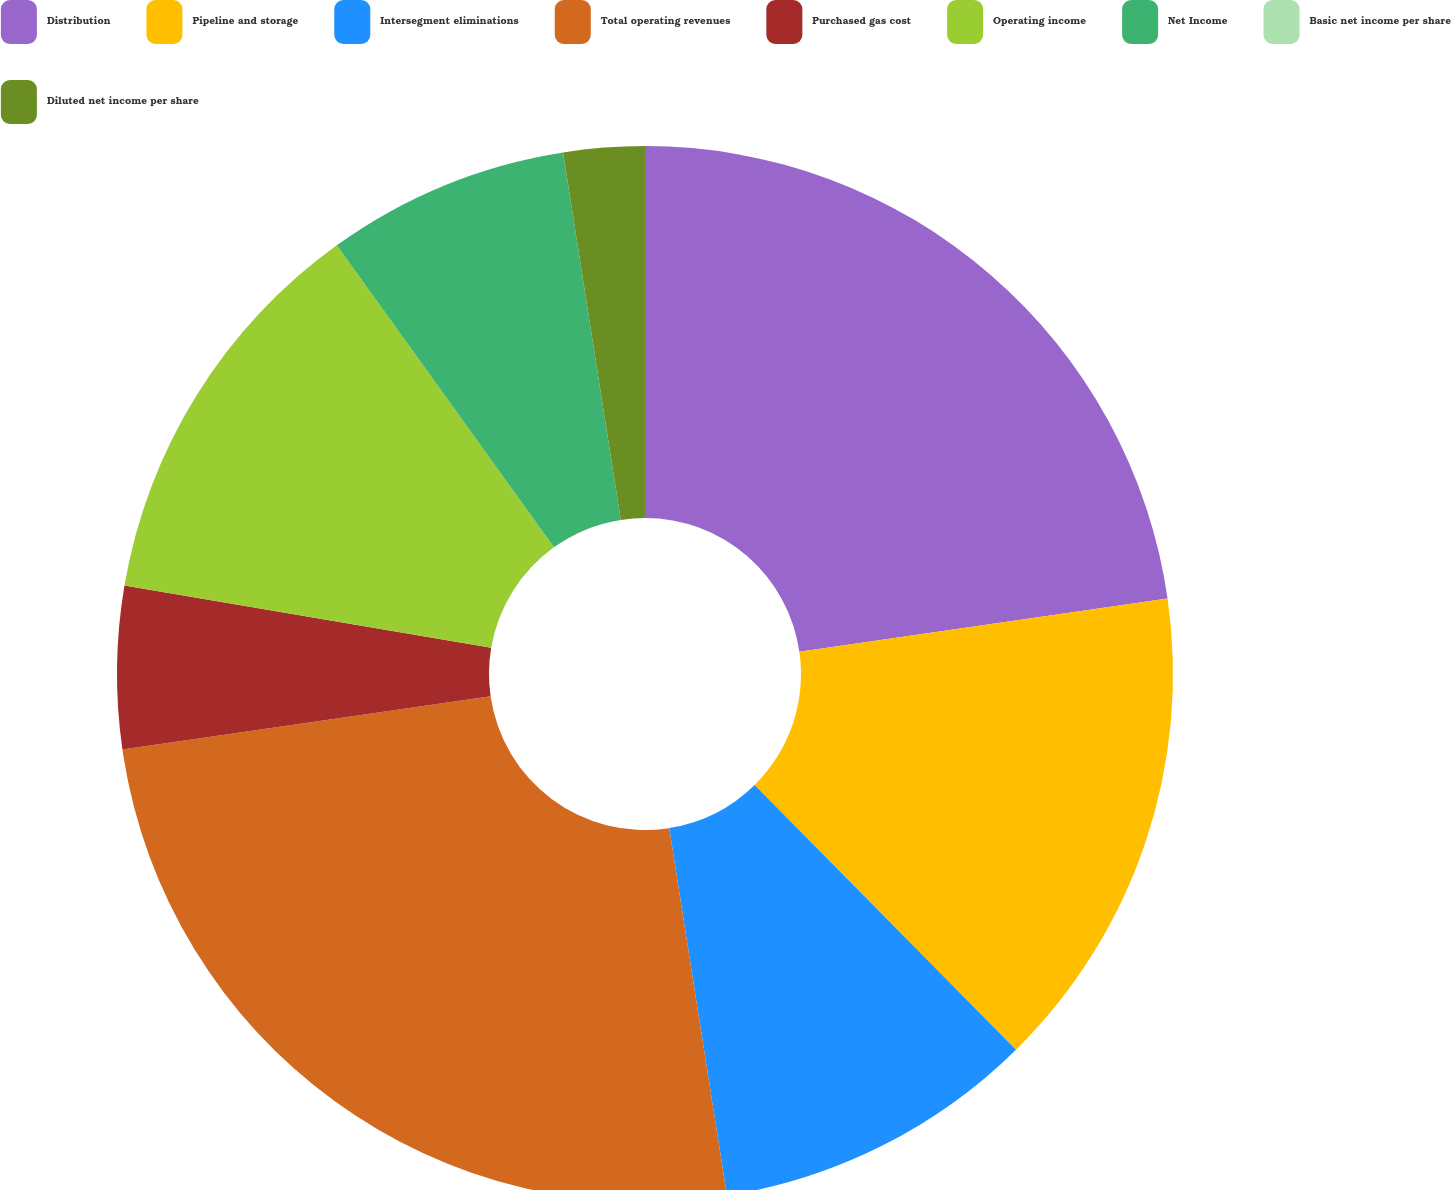Convert chart to OTSL. <chart><loc_0><loc_0><loc_500><loc_500><pie_chart><fcel>Distribution<fcel>Pipeline and storage<fcel>Intersegment eliminations<fcel>Total operating revenues<fcel>Purchased gas cost<fcel>Operating income<fcel>Net Income<fcel>Basic net income per share<fcel>Diluted net income per share<nl><fcel>22.72%<fcel>14.88%<fcel>9.92%<fcel>25.2%<fcel>4.96%<fcel>12.4%<fcel>7.44%<fcel>0.0%<fcel>2.48%<nl></chart> 